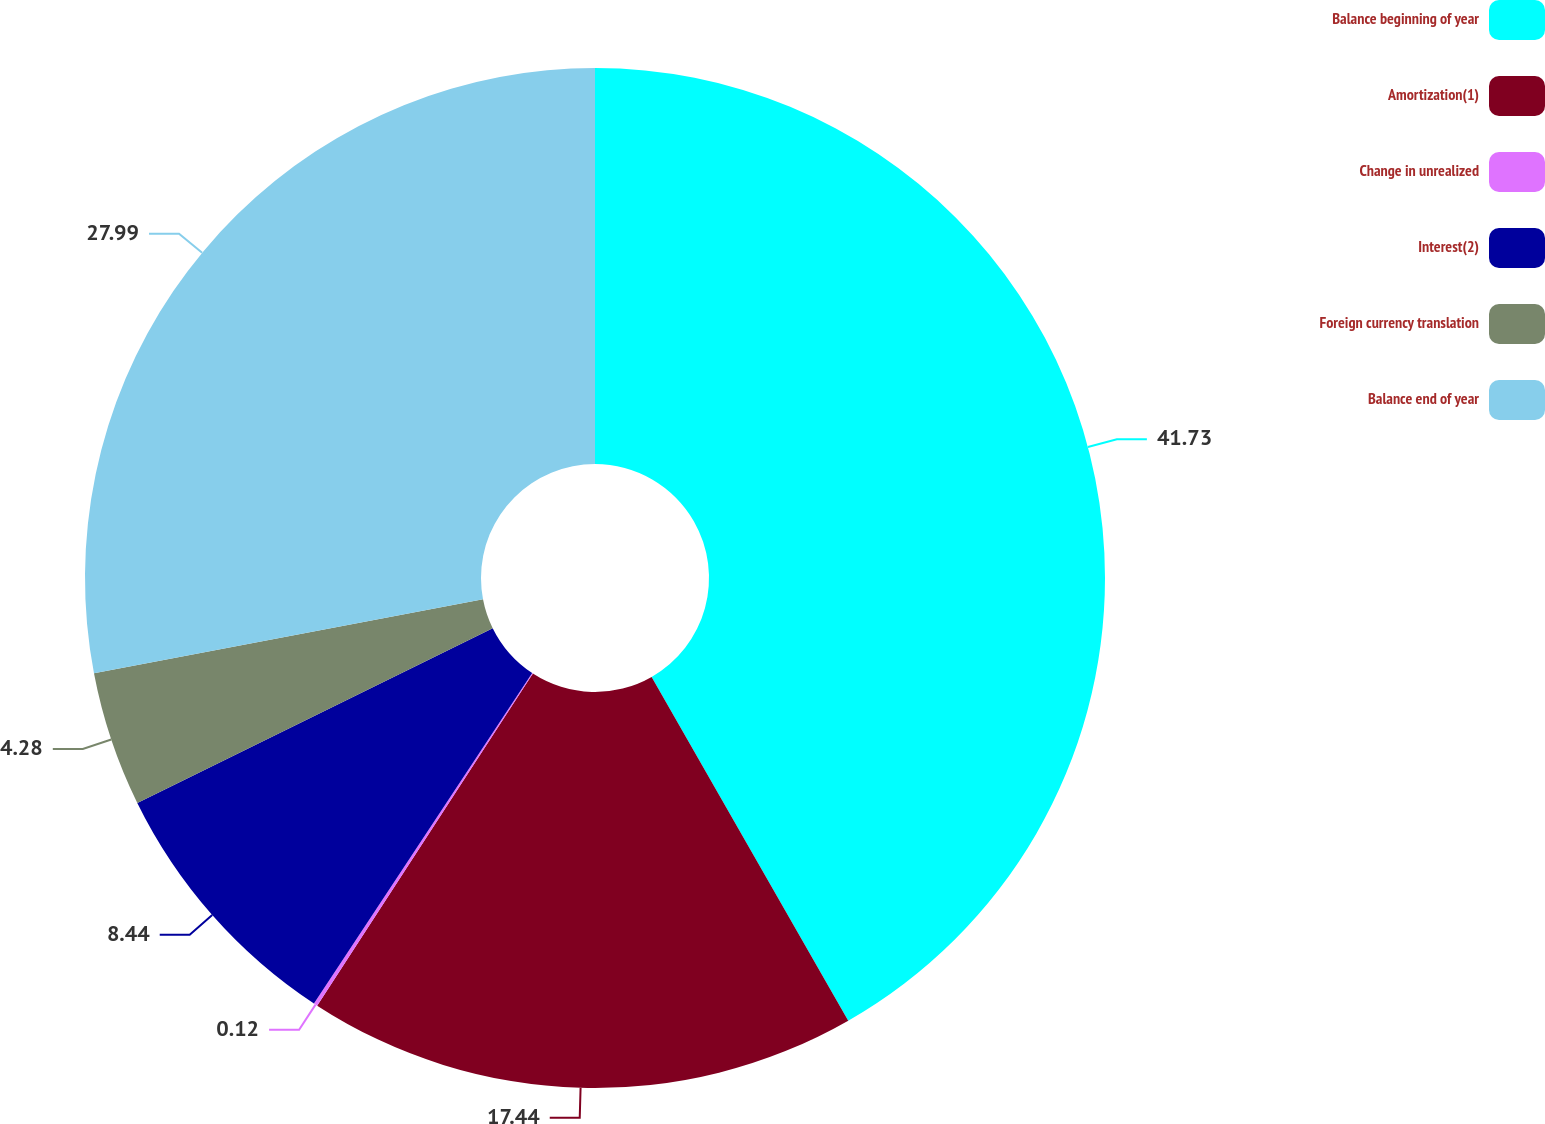Convert chart. <chart><loc_0><loc_0><loc_500><loc_500><pie_chart><fcel>Balance beginning of year<fcel>Amortization(1)<fcel>Change in unrealized<fcel>Interest(2)<fcel>Foreign currency translation<fcel>Balance end of year<nl><fcel>41.73%<fcel>17.44%<fcel>0.12%<fcel>8.44%<fcel>4.28%<fcel>27.99%<nl></chart> 